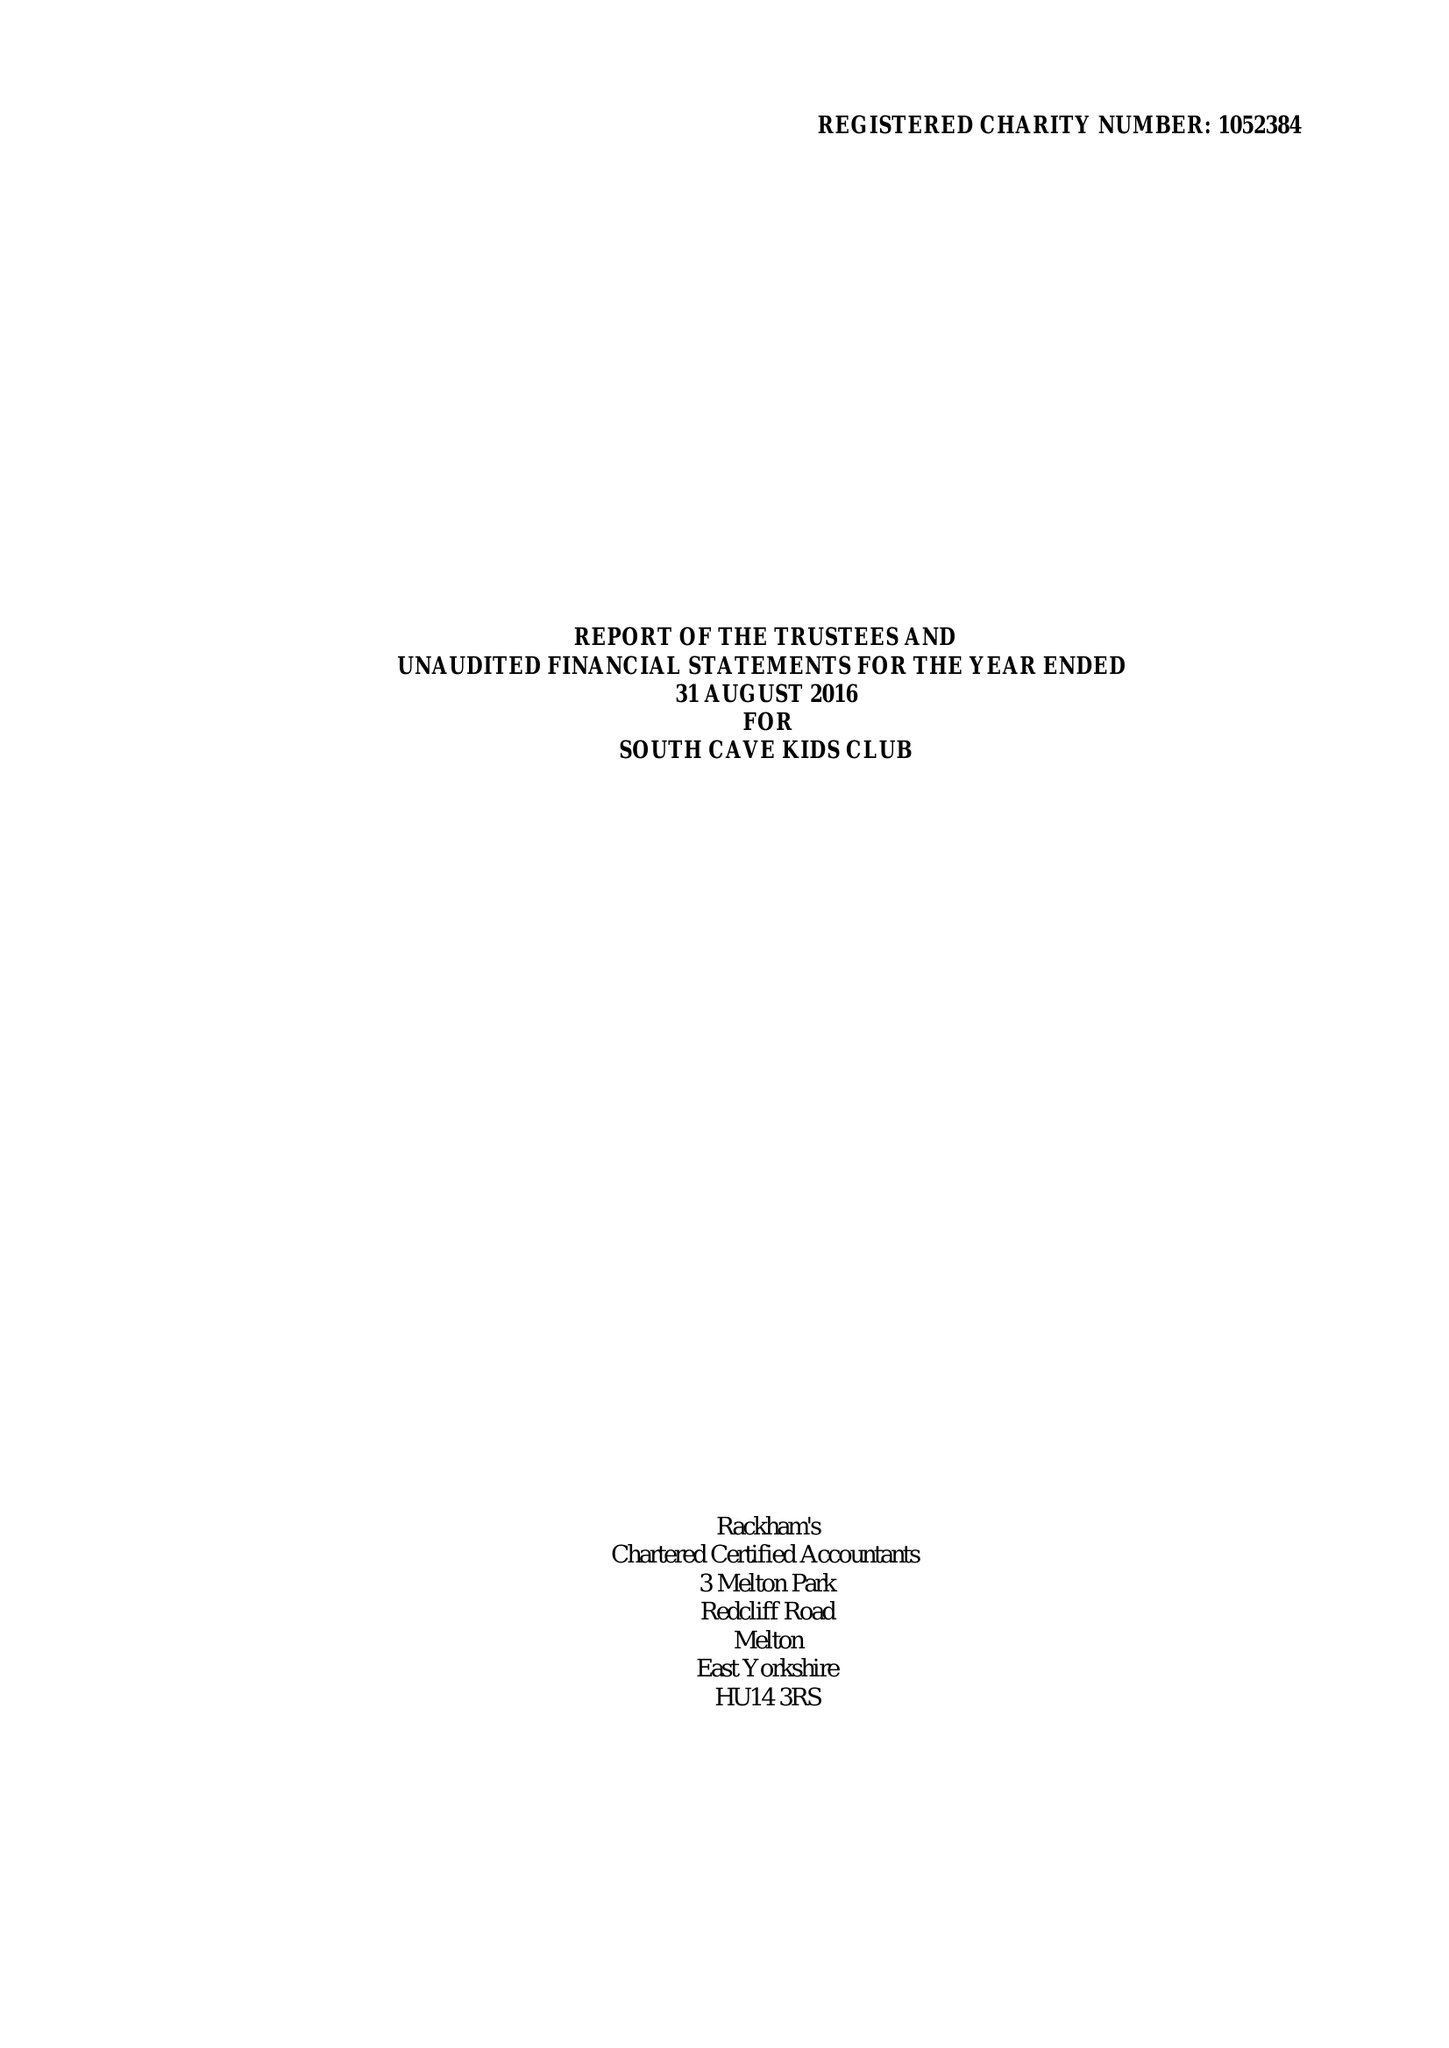What is the value for the charity_number?
Answer the question using a single word or phrase. 1052384 